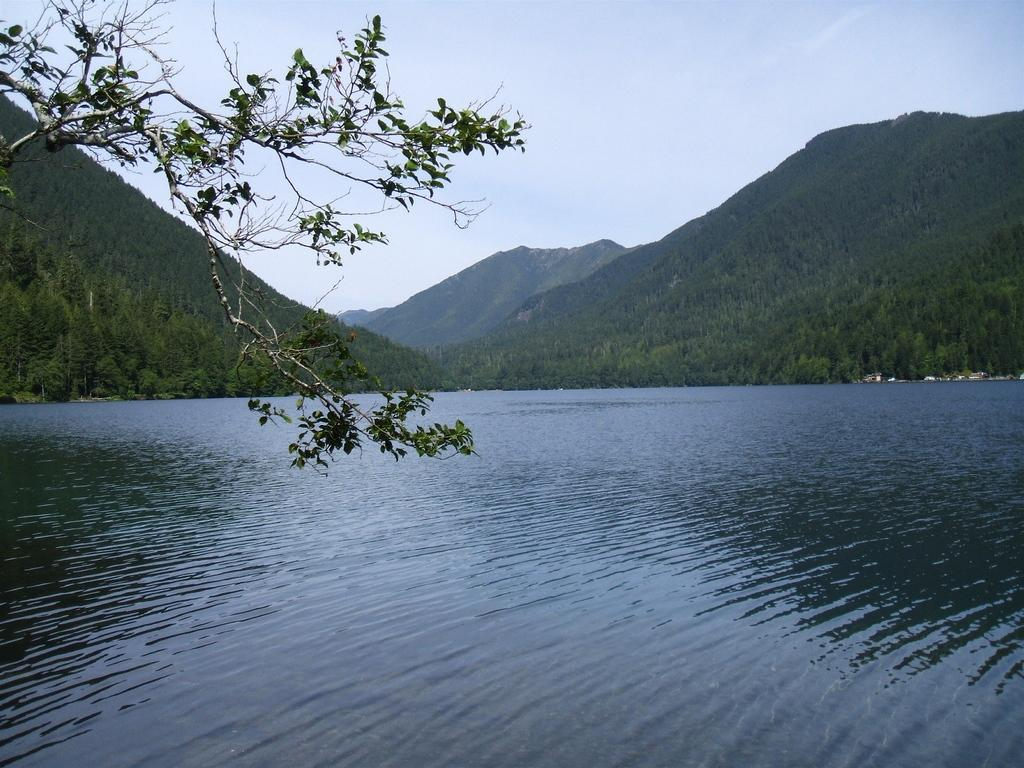What is visible in the image? Water, trees, mountains, and the sky are visible in the image. Can you describe the natural environment in the image? The image features water, trees, and mountains, which are all part of the natural environment. What is the condition of the sky in the image? The sky is visible at the top of the image. How many adjustments were made to the lake in the image? There is no lake present in the image, so no adjustments can be made to it. What type of request can be seen being made in the image? There is no request visible in the image; it features water, trees, mountains, and the sky. 